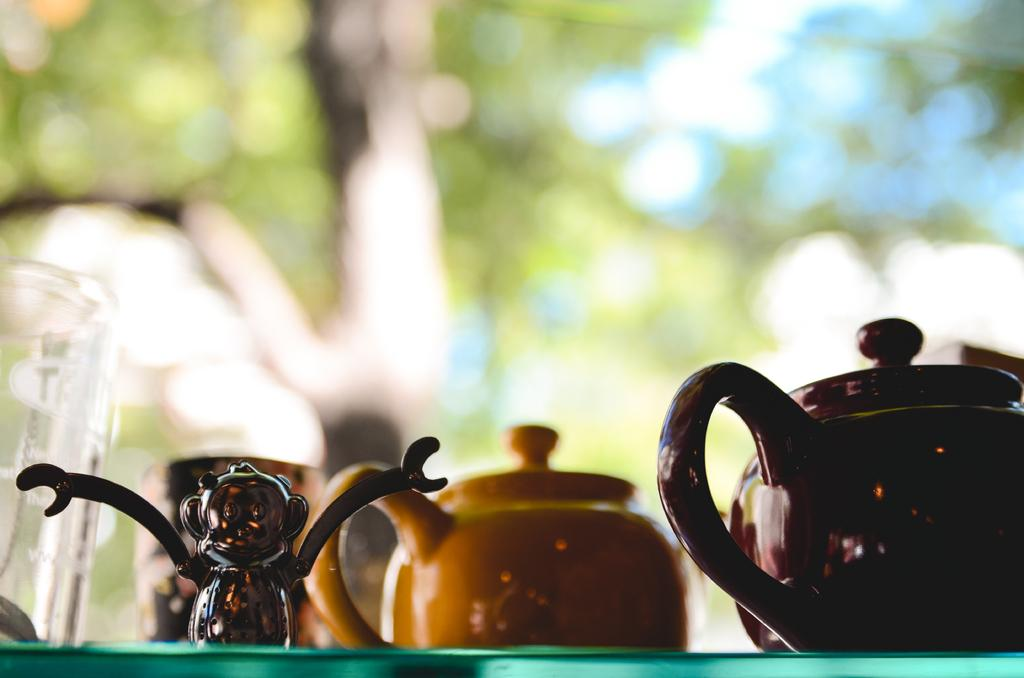What type of object can be seen in the image? There is a toy in the image. What else is present in the image besides the toy? There is a glass and tea pots in the image. Where are these objects located? The objects are on a platform. Can you describe the background of the image? The background of the image is blurred, but there are visible objects in the background. What is the father doing in the image? There is no father present in the image. What is the chance of winning a prize in the image? There is no mention of a prize or winning in the image. 